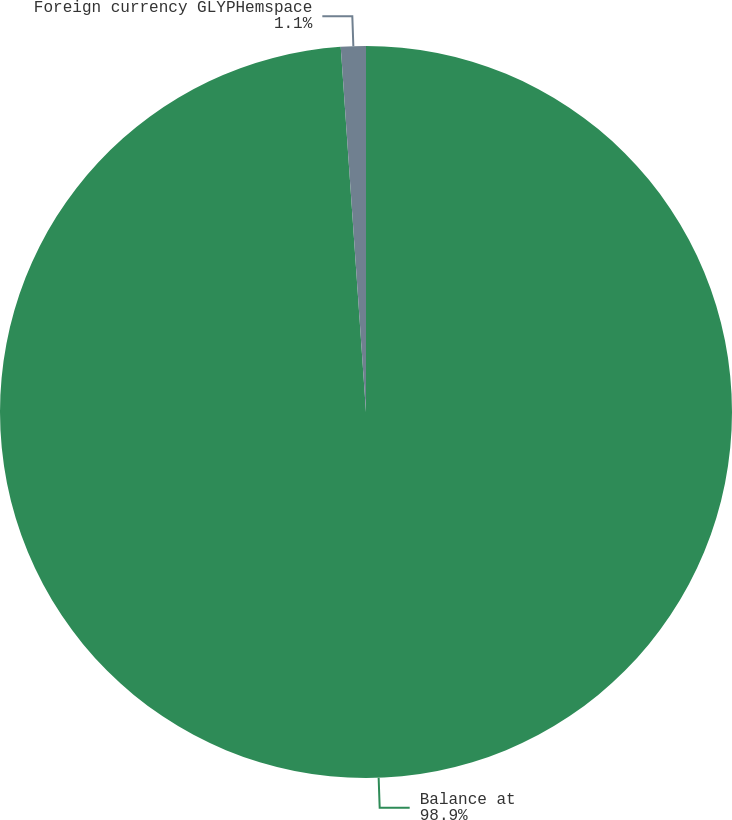Convert chart. <chart><loc_0><loc_0><loc_500><loc_500><pie_chart><fcel>Balance at<fcel>Foreign currency GLYPHemspace<nl><fcel>98.9%<fcel>1.1%<nl></chart> 